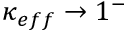Convert formula to latex. <formula><loc_0><loc_0><loc_500><loc_500>\kappa _ { e f f } \rightarrow 1 ^ { - }</formula> 